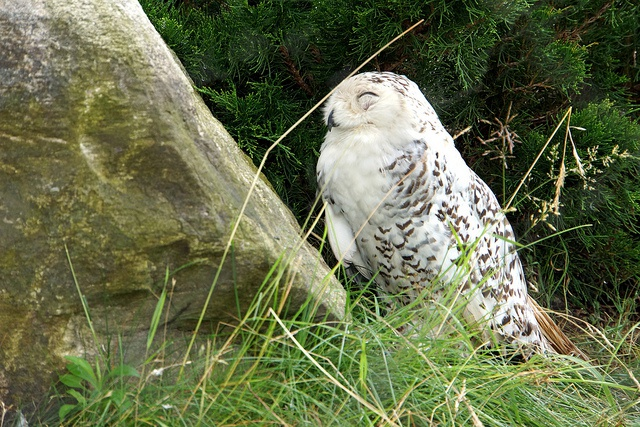Describe the objects in this image and their specific colors. I can see a bird in tan, lightgray, darkgray, gray, and olive tones in this image. 